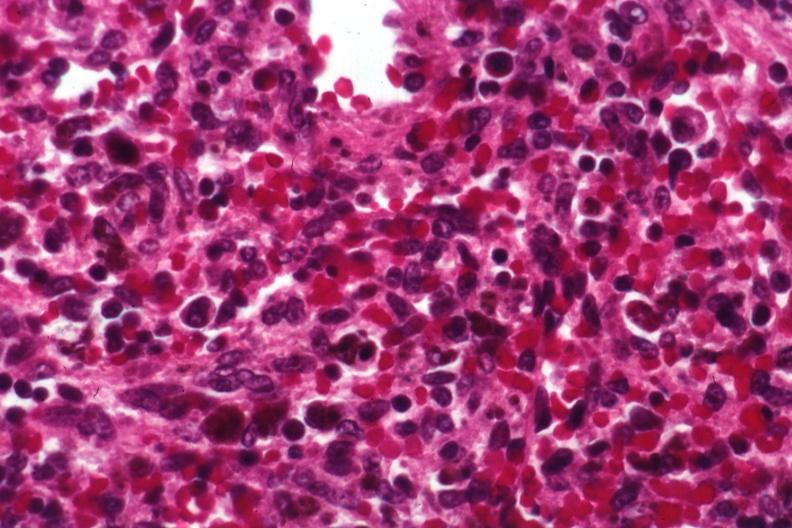s chromophobe adenoma present?
Answer the question using a single word or phrase. No 